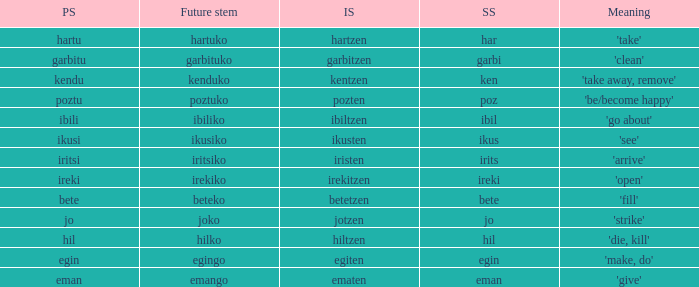What is the perfect stem for pozten? Poztu. 